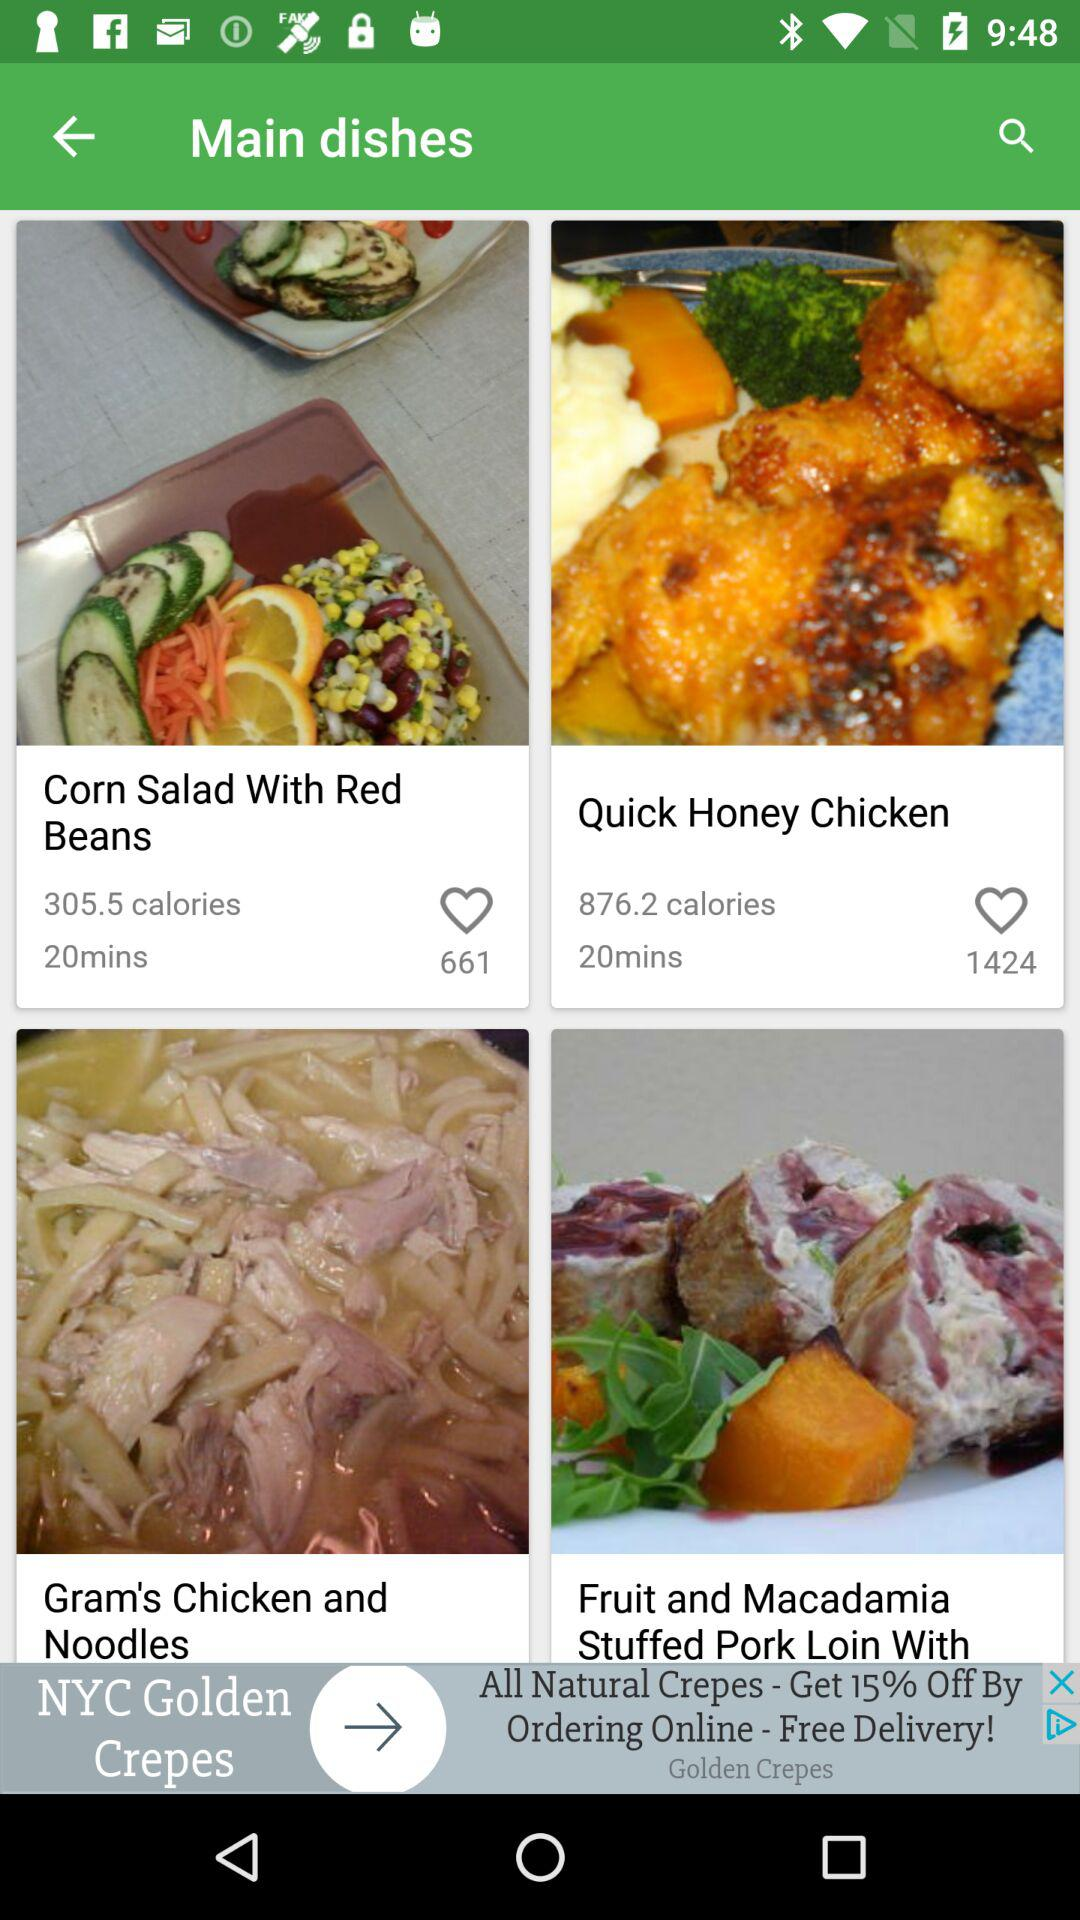How many Calories does "Corn Salad With Red Beans" contain? It contains 305.5 calories. 